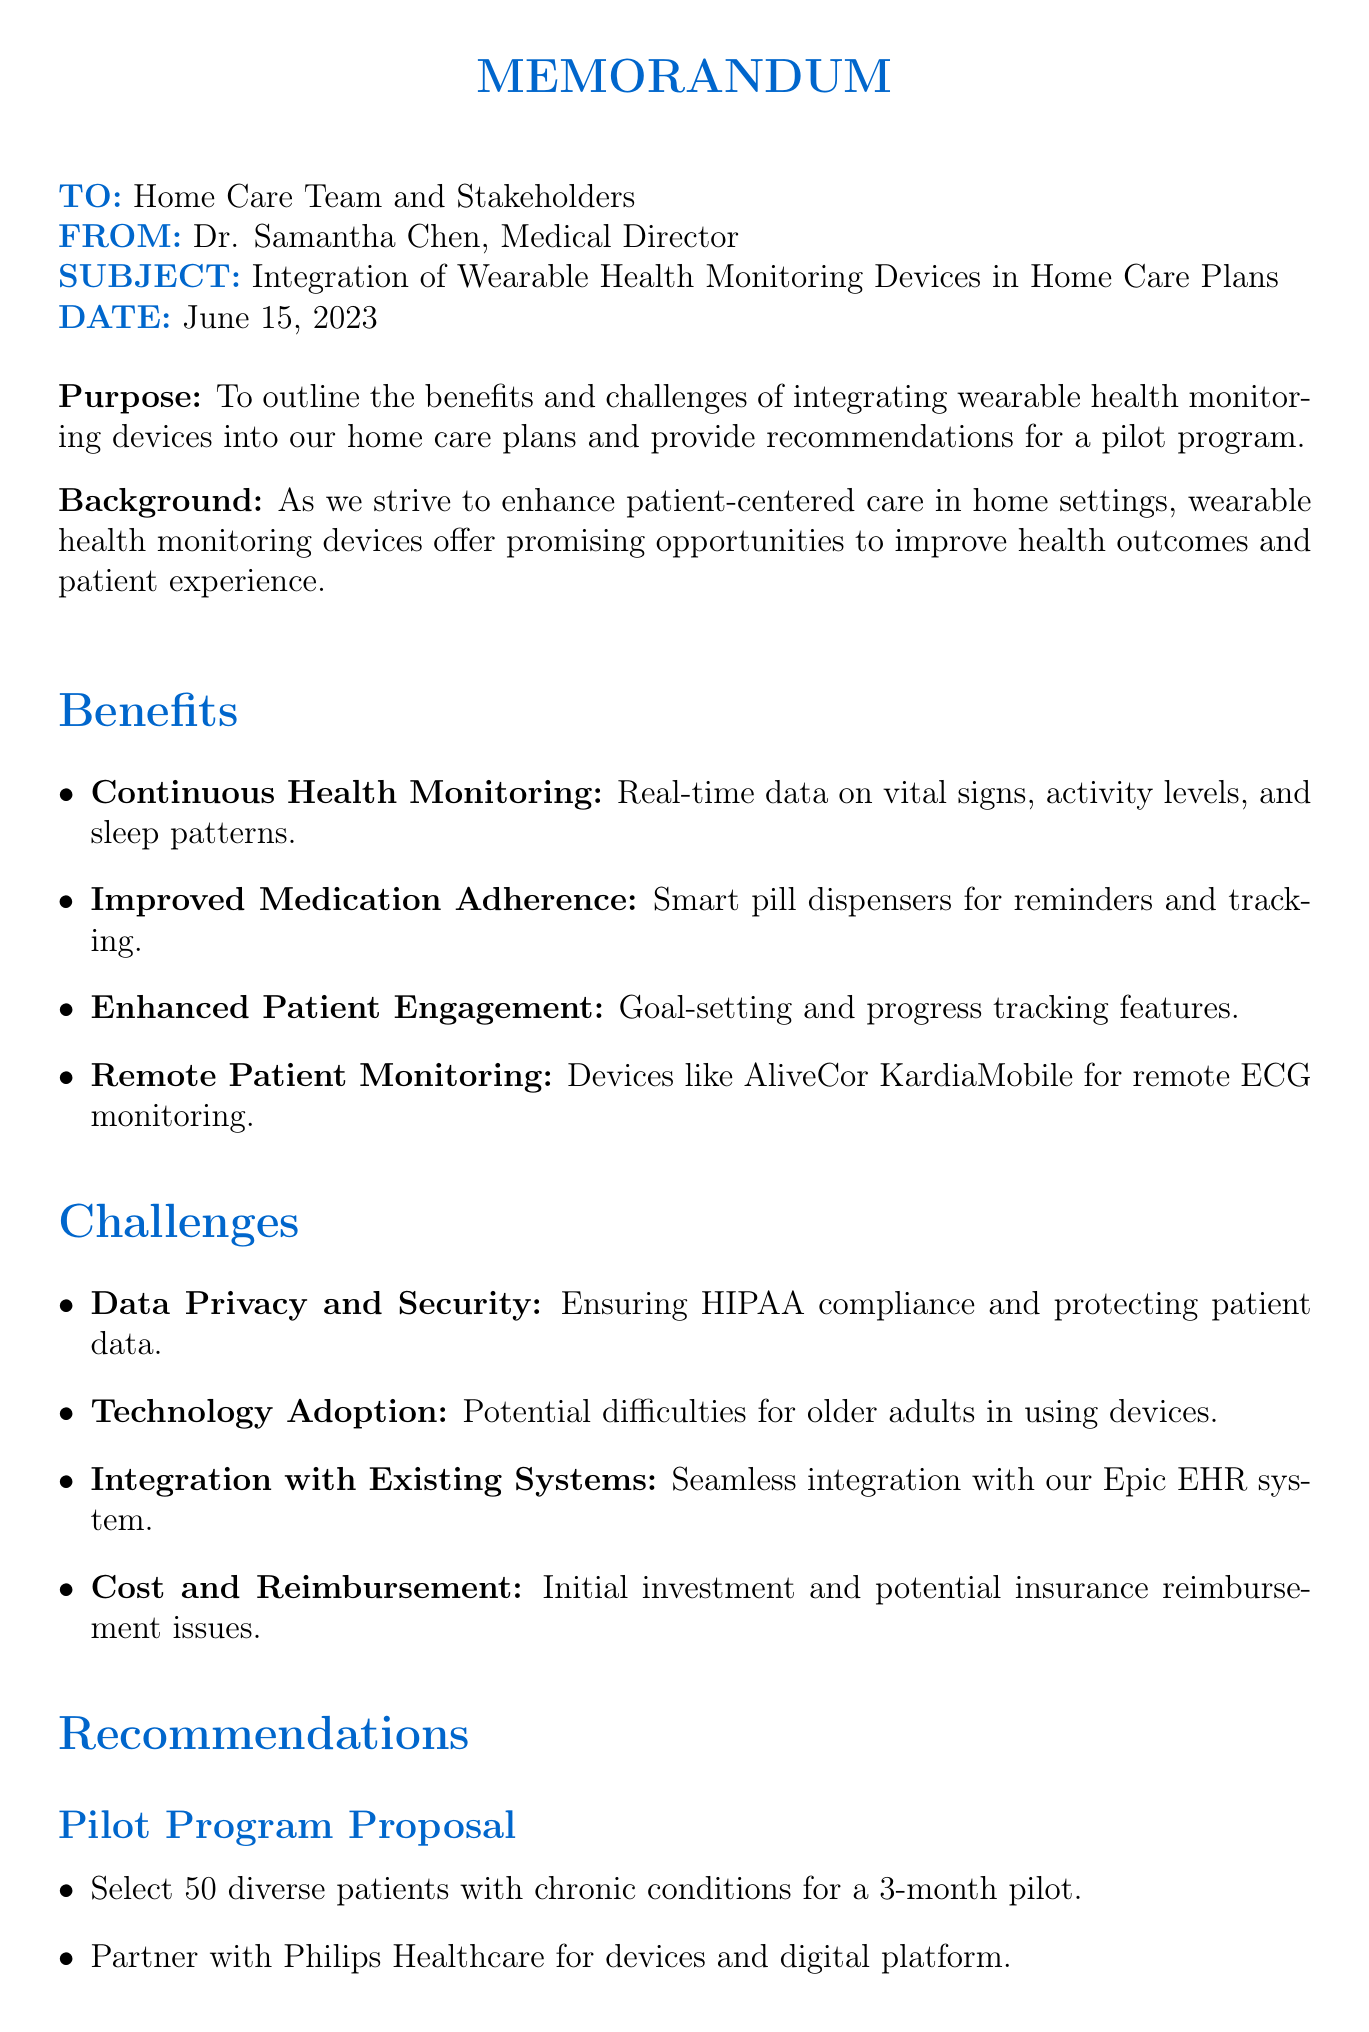What is the date of the memo? The date of the memo is listed in the header section.
Answer: June 15, 2023 Who is the author of the memo? The author of the memo is indicated in the header section.
Answer: Dr. Samantha Chen What is one benefit of using wearable health monitoring devices? This information can be found in the benefits section of the document.
Answer: Continuous Health Monitoring What challenge is associated with technology adoption? This challenge is mentioned in the challenges section and refers to a specific demographic.
Answer: Older adults How long is the proposed pilot program? The duration of the pilot program is mentioned in the recommendations section.
Answer: 3 months What is one of the key performance indicators? Key performance indicators are listed in the recommendations section.
Answer: Patient engagement rates What action is suggested as the next step after the pilot program? This action is described in the conclusion section.
Answer: Assemble a multidisciplinary team Which company is proposed to partner with for the pilot program? The partner company is mentioned in the recommendations section of the memo.
Answer: Philips Healthcare How many patients are proposed for the pilot program? The number of patients selected for the pilot program is indicated in the recommendations section.
Answer: 50 patients 